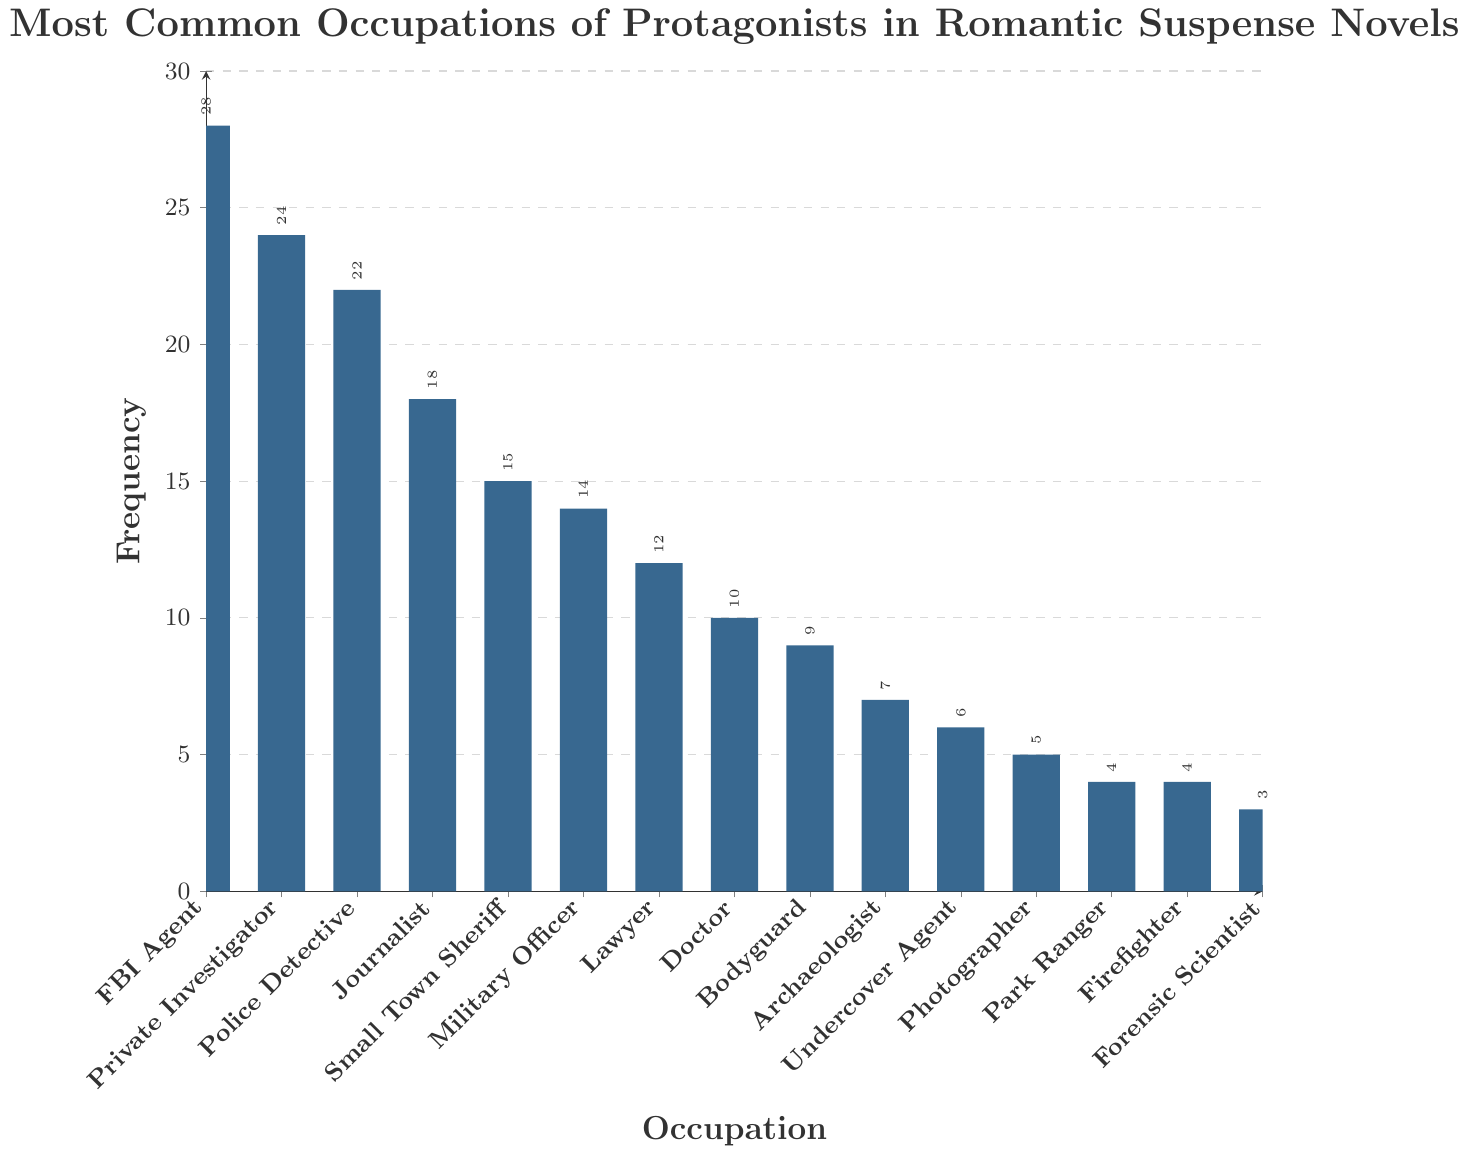Which occupation is the most common among protagonists in romantic suspense novels? The highest bar in the chart represents the most common occupation. In this case, it is labeled "FBI Agent" with a frequency of 28.
Answer: FBI Agent How many more FBI Agents are there compared to Forensic Scientists? The frequency of FBI Agents is 28, and Forensic Scientists is 3. Subtract the number of Forensic Scientists from FBI Agents: 28 - 3 = 25.
Answer: 25 Which occupation has a frequency equal to half the frequency of Private Investigators? The frequency of Private Investigators is 24. Half of 24 is 12. The occupation with a frequency of 12 is Lawyer.
Answer: Lawyer How does the frequency of Journalists compare to that of Military Officers? The frequency of Journalists is 18, and the frequency of Military Officers is 14. Since 18 is greater than 14, Journalists have a higher frequency.
Answer: Journalists have a higher frequency What is the total frequency of Small Town Sheriffs, Military Officers, and Lawyers combined? Add the frequencies together: Small Town Sheriff (15) + Military Officer (14) + Lawyer (12) = 41.
Answer: 41 What is the most frequent occupation after FBI Agents and Private Investigators? The most frequent occupation after FBI Agents (28) and Private Investigators (24) is Police Detective (22).
Answer: Police Detective Find the sum of the frequencies of the three least common occupations. The three least common occupations are Forensic Scientist (3), Park Ranger (4), and Firefighter (4). Sum them up: 3 + 4 + 4 = 11.
Answer: 11 Are there more Doctors or Bodyguards in romantic suspense novels? The frequency of Doctors is 10, and the frequency of Bodyguards is 9. Since 10 is greater than 9, there are more Doctors.
Answer: Doctors What’s the range of frequencies for all the occupations listed? The range is the difference between the highest and the lowest frequencies. The highest frequency is FBI Agent (28) and the lowest is Forensic Scientist (3). The range is 28 - 3 = 25.
Answer: 25 Which two occupations have the same frequency and what is that frequency? The occupations Park Ranger and Firefighter both have a frequency of 4.
Answer: Park Ranger and Firefighter, 4 